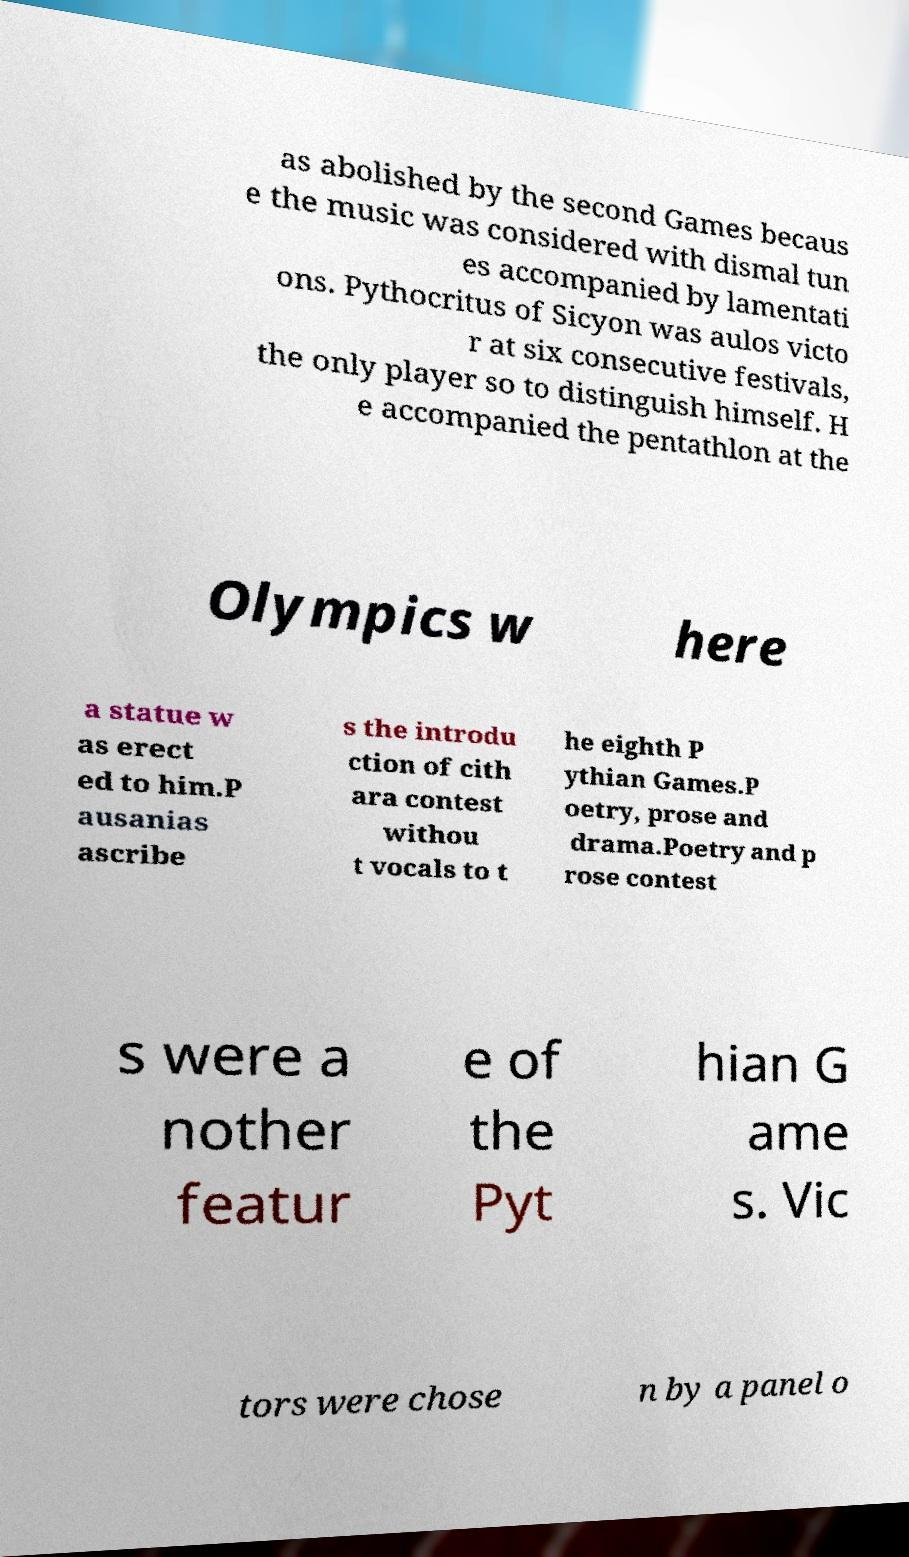There's text embedded in this image that I need extracted. Can you transcribe it verbatim? as abolished by the second Games becaus e the music was considered with dismal tun es accompanied by lamentati ons. Pythocritus of Sicyon was aulos victo r at six consecutive festivals, the only player so to distinguish himself. H e accompanied the pentathlon at the Olympics w here a statue w as erect ed to him.P ausanias ascribe s the introdu ction of cith ara contest withou t vocals to t he eighth P ythian Games.P oetry, prose and drama.Poetry and p rose contest s were a nother featur e of the Pyt hian G ame s. Vic tors were chose n by a panel o 